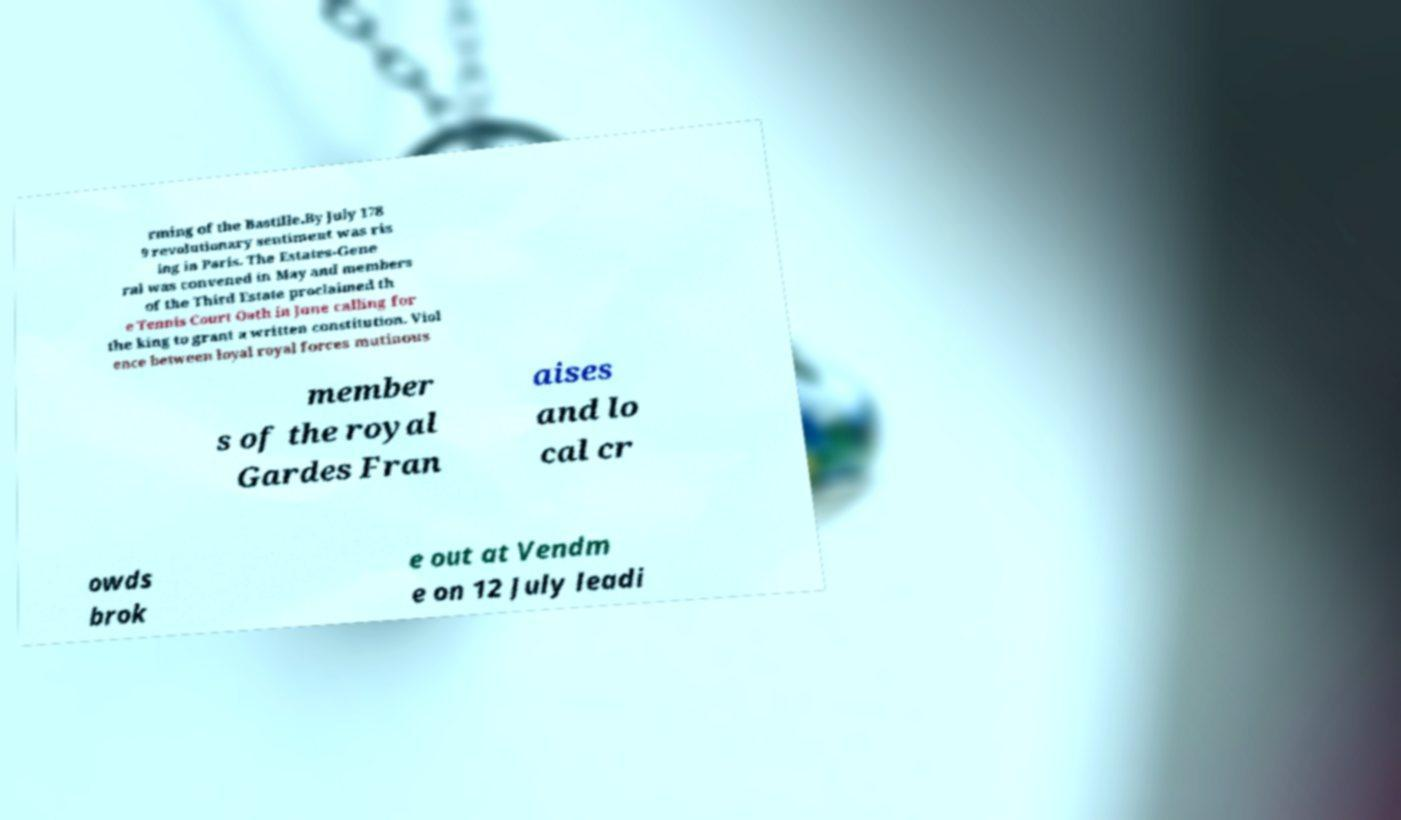Can you read and provide the text displayed in the image?This photo seems to have some interesting text. Can you extract and type it out for me? rming of the Bastille.By July 178 9 revolutionary sentiment was ris ing in Paris. The Estates-Gene ral was convened in May and members of the Third Estate proclaimed th e Tennis Court Oath in June calling for the king to grant a written constitution. Viol ence between loyal royal forces mutinous member s of the royal Gardes Fran aises and lo cal cr owds brok e out at Vendm e on 12 July leadi 